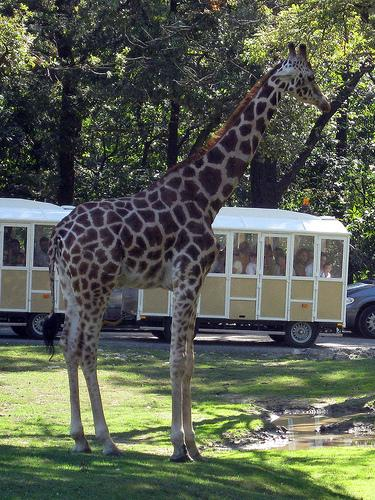Mention the most prominent animal in the image and its features. A giraffe with a long neck, spots, and long legs is the main animal, its head is looking downward, and it has a long tail with black hair at the end. Tell a story of what could be happening in the image. A group of tourists on a safari are excited to watch a majestic giraffe nearby, surrounded by green trees, making the moment extra special for them. Provide an overview of the picture, paying attention to the setting and environment. In a peaceful natural setting, with green grass and trees, a tall, long-necked giraffe draws the attention of tourists in a nearby tan tour bus. Write a brief account of the image, focusing on the interactions between the subjects. A group of people inside a tour bus are looking towards a large giraffe in a natural setting, with trees, branches, and green grass as the backdrop. Offer a description of the image concentrating on the colors and other visual aspects. A vivid image showcasing the contrast of a large, spotted giraffe against green trees, grass, and white and gray cars, capturing the attention of curious observers. Illustrate the scene briefly, focusing on what the people are doing. People watch in awe as they get a close encounter with a captivating giraffe from the safety of their tour vehicle, surrounded by a lush green environment. Give a summary of the image by highlighting the key elements. The image features a giraffe with brown spots, a tour bus with people watching, green trees, a grey car, and a trolley car in the background. Narrate a scene that focuses on the primary subject and its surroundings. A tall and large giraffe with brown spots is standing on the grass, surrounded by green trees, muddy water and people watching from a tour bus. Outline the main elements of the image, concentrating on the setting and any vehicles present. A large giraffe on a grassy setting stands amidst green trees and vehicles, like a grey car, trolley car and a tan tour bus filled with curious observers. Describe the scenery with emphasis on the natural and man-made objects. Green trees and grass set a backdrop for a giraffe, while a grey car, a trolley car, and a tan tour bus with white roof gather around the scene. 